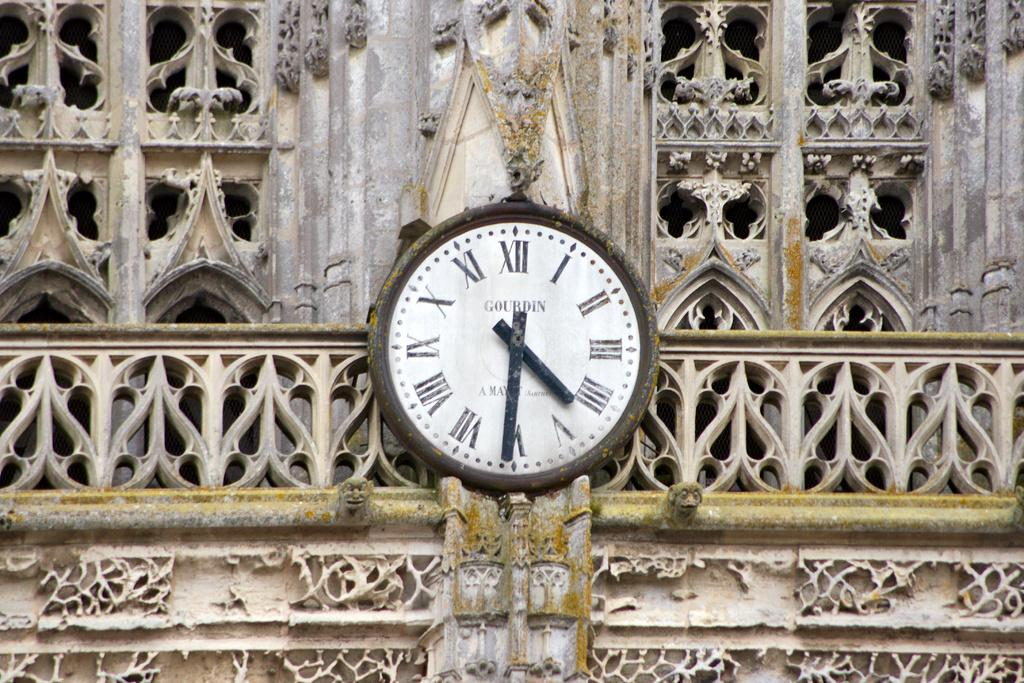What object is hanging on the wall in the image? There is a clock on the wall in the image. What type of architectural feature can be seen in the image? There are railings visible in the image. What other structural elements are present in the image? There are pillars in the image. Can you tell me how many caps are on the pillars in the image? There are no caps present on the pillars in the image. What message of peace can be seen in the image? There is no message of peace depicted in the image. 